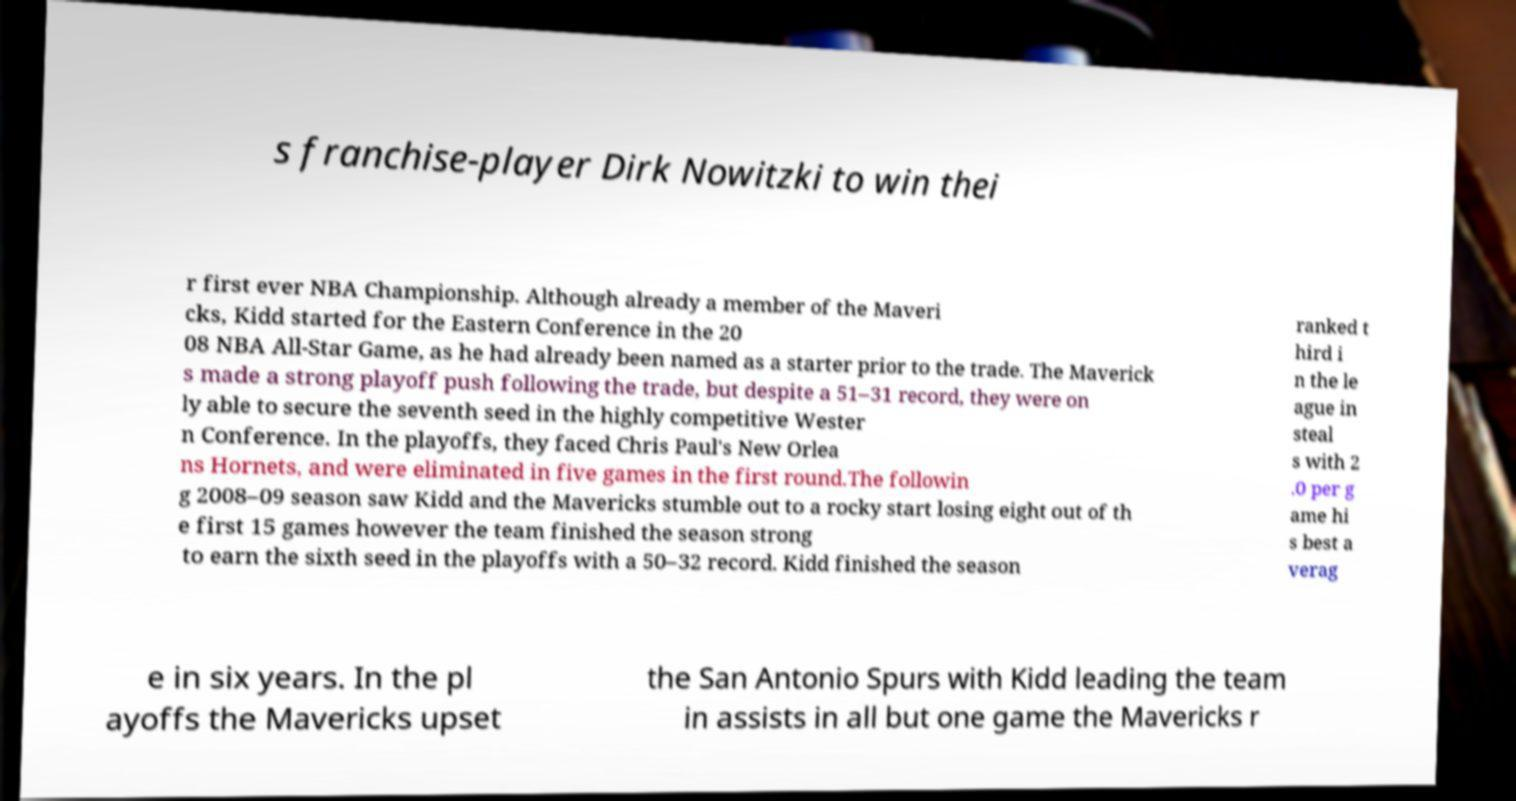I need the written content from this picture converted into text. Can you do that? s franchise-player Dirk Nowitzki to win thei r first ever NBA Championship. Although already a member of the Maveri cks, Kidd started for the Eastern Conference in the 20 08 NBA All-Star Game, as he had already been named as a starter prior to the trade. The Maverick s made a strong playoff push following the trade, but despite a 51–31 record, they were on ly able to secure the seventh seed in the highly competitive Wester n Conference. In the playoffs, they faced Chris Paul's New Orlea ns Hornets, and were eliminated in five games in the first round.The followin g 2008–09 season saw Kidd and the Mavericks stumble out to a rocky start losing eight out of th e first 15 games however the team finished the season strong to earn the sixth seed in the playoffs with a 50–32 record. Kidd finished the season ranked t hird i n the le ague in steal s with 2 .0 per g ame hi s best a verag e in six years. In the pl ayoffs the Mavericks upset the San Antonio Spurs with Kidd leading the team in assists in all but one game the Mavericks r 